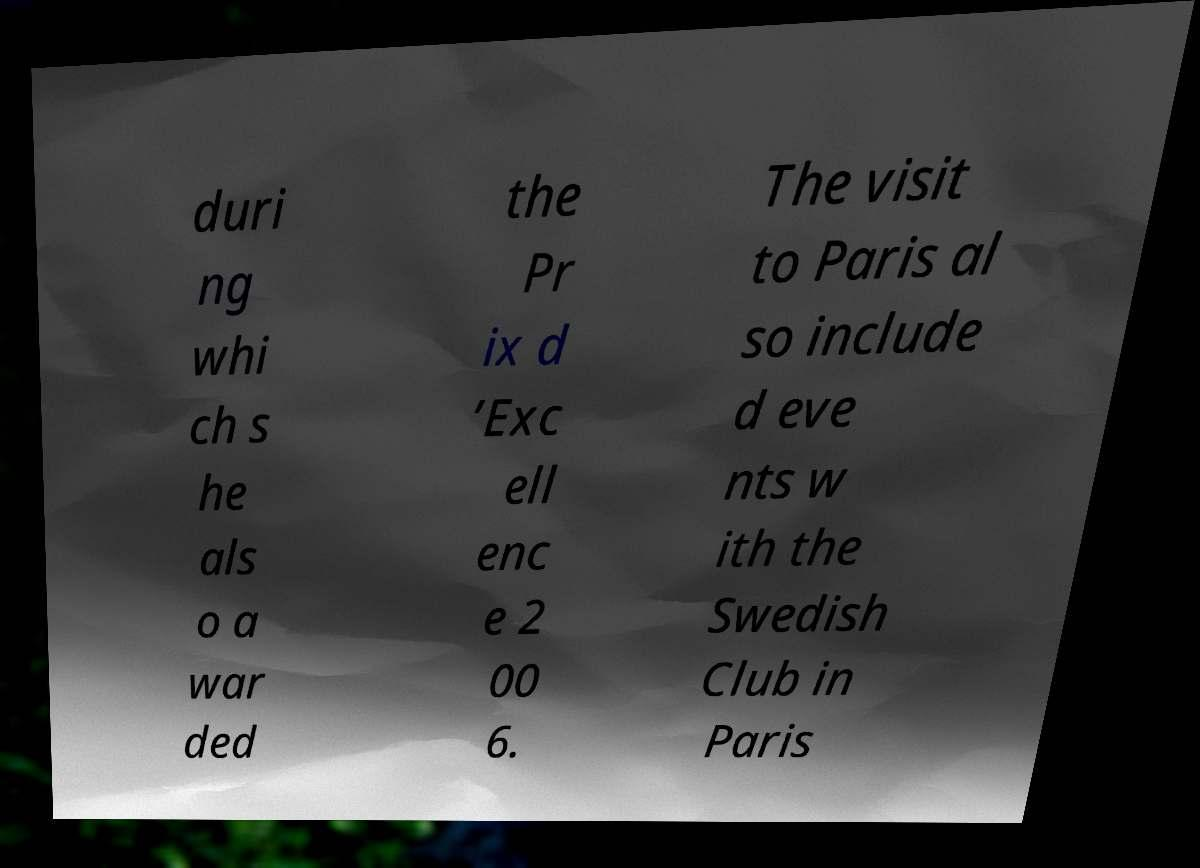There's text embedded in this image that I need extracted. Can you transcribe it verbatim? duri ng whi ch s he als o a war ded the Pr ix d ’Exc ell enc e 2 00 6. The visit to Paris al so include d eve nts w ith the Swedish Club in Paris 